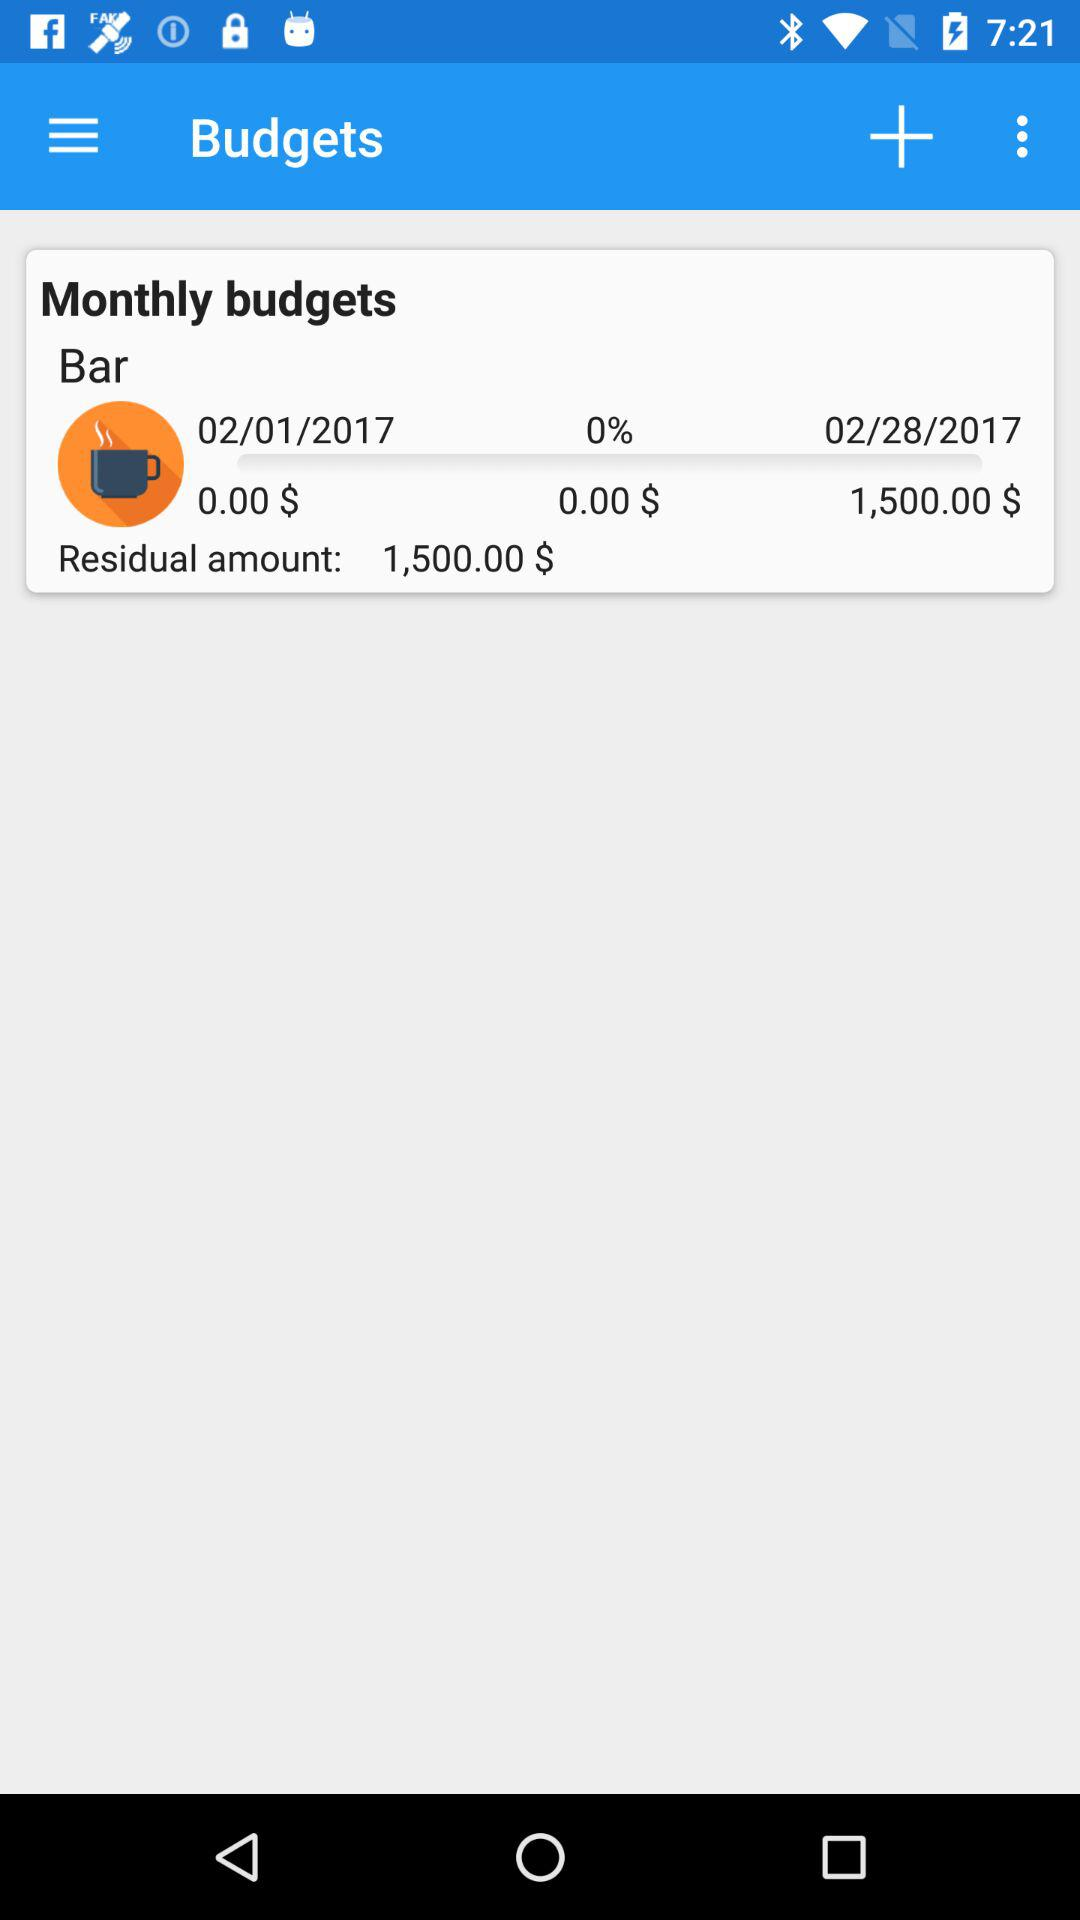What is the total budget of the bar from February 1, 2017 to February 28, 2017? The total budget of the bar from February 1, 2017 to February 28, 2017 is 1,500 dollars. 